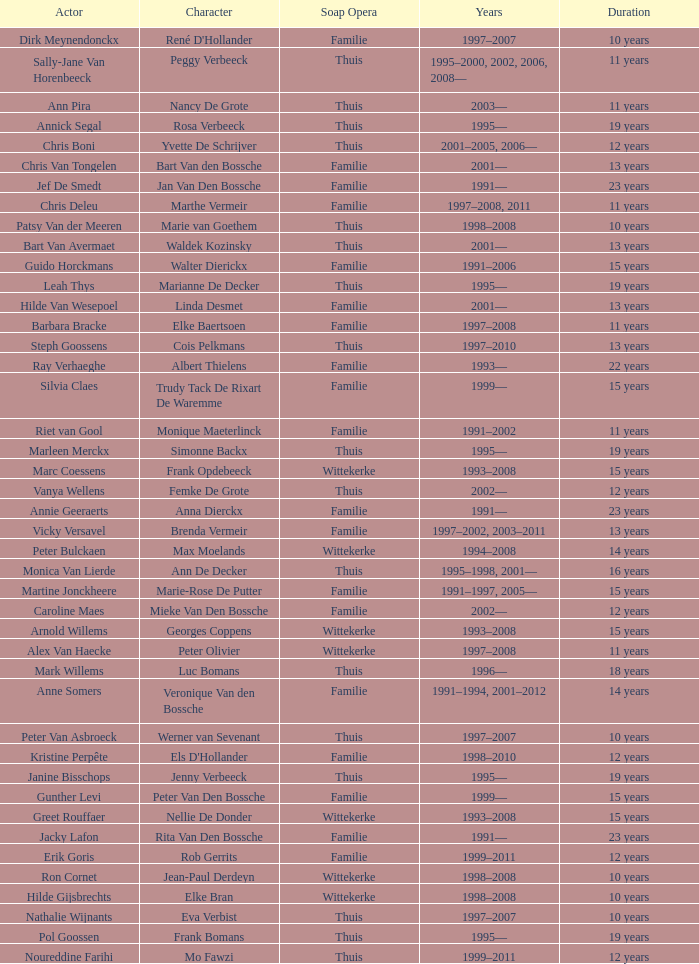What actor plays Marie-Rose De Putter? Martine Jonckheere. 